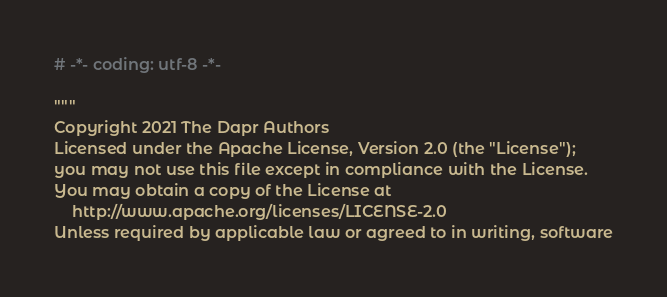Convert code to text. <code><loc_0><loc_0><loc_500><loc_500><_Python_># -*- coding: utf-8 -*-

"""
Copyright 2021 The Dapr Authors
Licensed under the Apache License, Version 2.0 (the "License");
you may not use this file except in compliance with the License.
You may obtain a copy of the License at
    http://www.apache.org/licenses/LICENSE-2.0
Unless required by applicable law or agreed to in writing, software</code> 